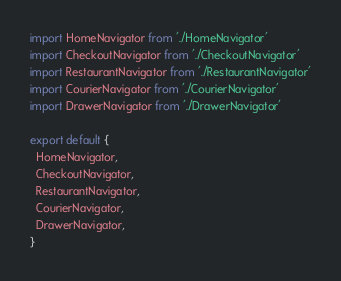Convert code to text. <code><loc_0><loc_0><loc_500><loc_500><_JavaScript_>import HomeNavigator from './HomeNavigator'
import CheckoutNavigator from './CheckoutNavigator'
import RestaurantNavigator from './RestaurantNavigator'
import CourierNavigator from './CourierNavigator'
import DrawerNavigator from './DrawerNavigator'

export default {
  HomeNavigator,
  CheckoutNavigator,
  RestaurantNavigator,
  CourierNavigator,
  DrawerNavigator,
}
</code> 